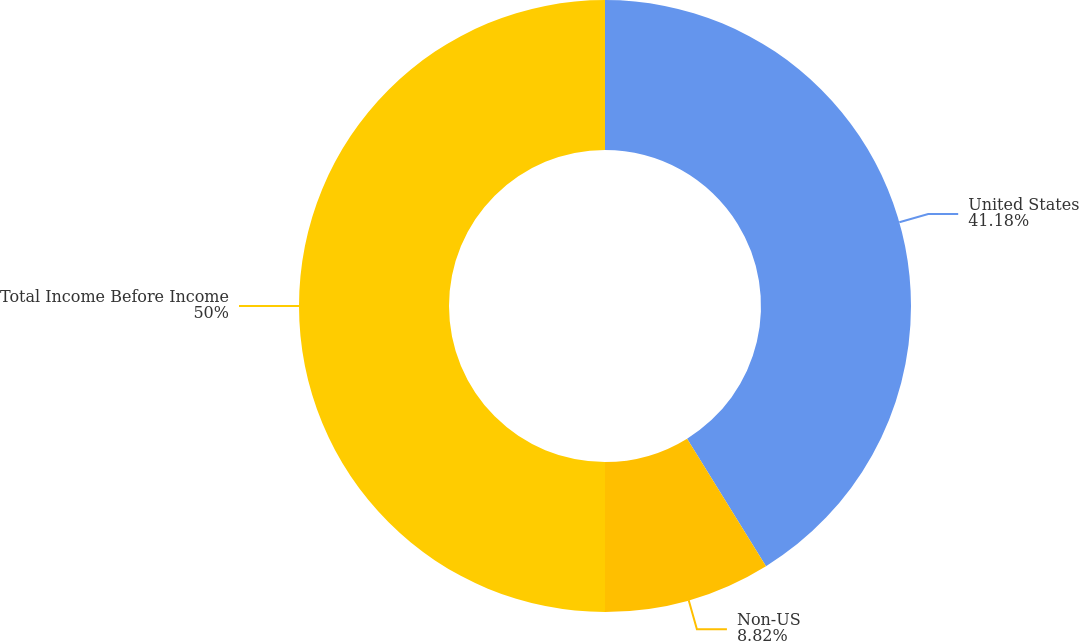<chart> <loc_0><loc_0><loc_500><loc_500><pie_chart><fcel>United States<fcel>Non-US<fcel>Total Income Before Income<nl><fcel>41.18%<fcel>8.82%<fcel>50.0%<nl></chart> 